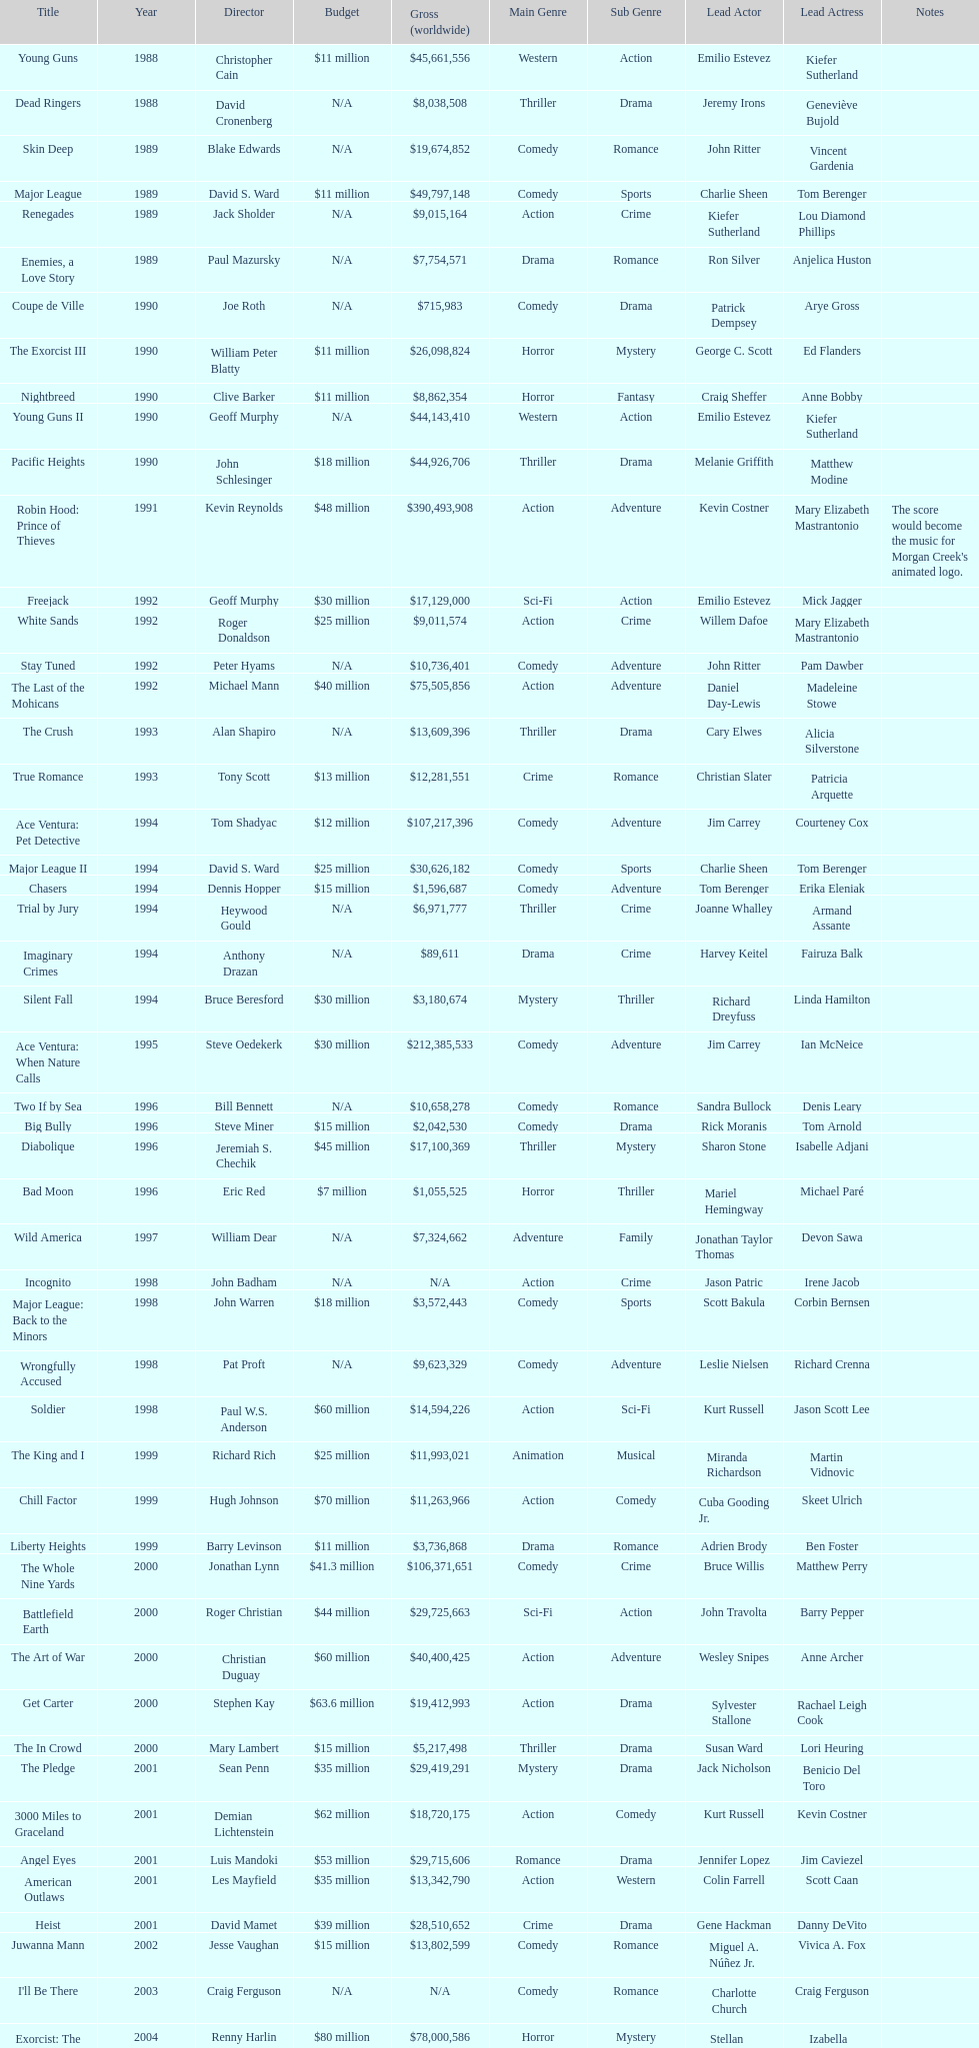What is the top grossing film? Robin Hood: Prince of Thieves. 